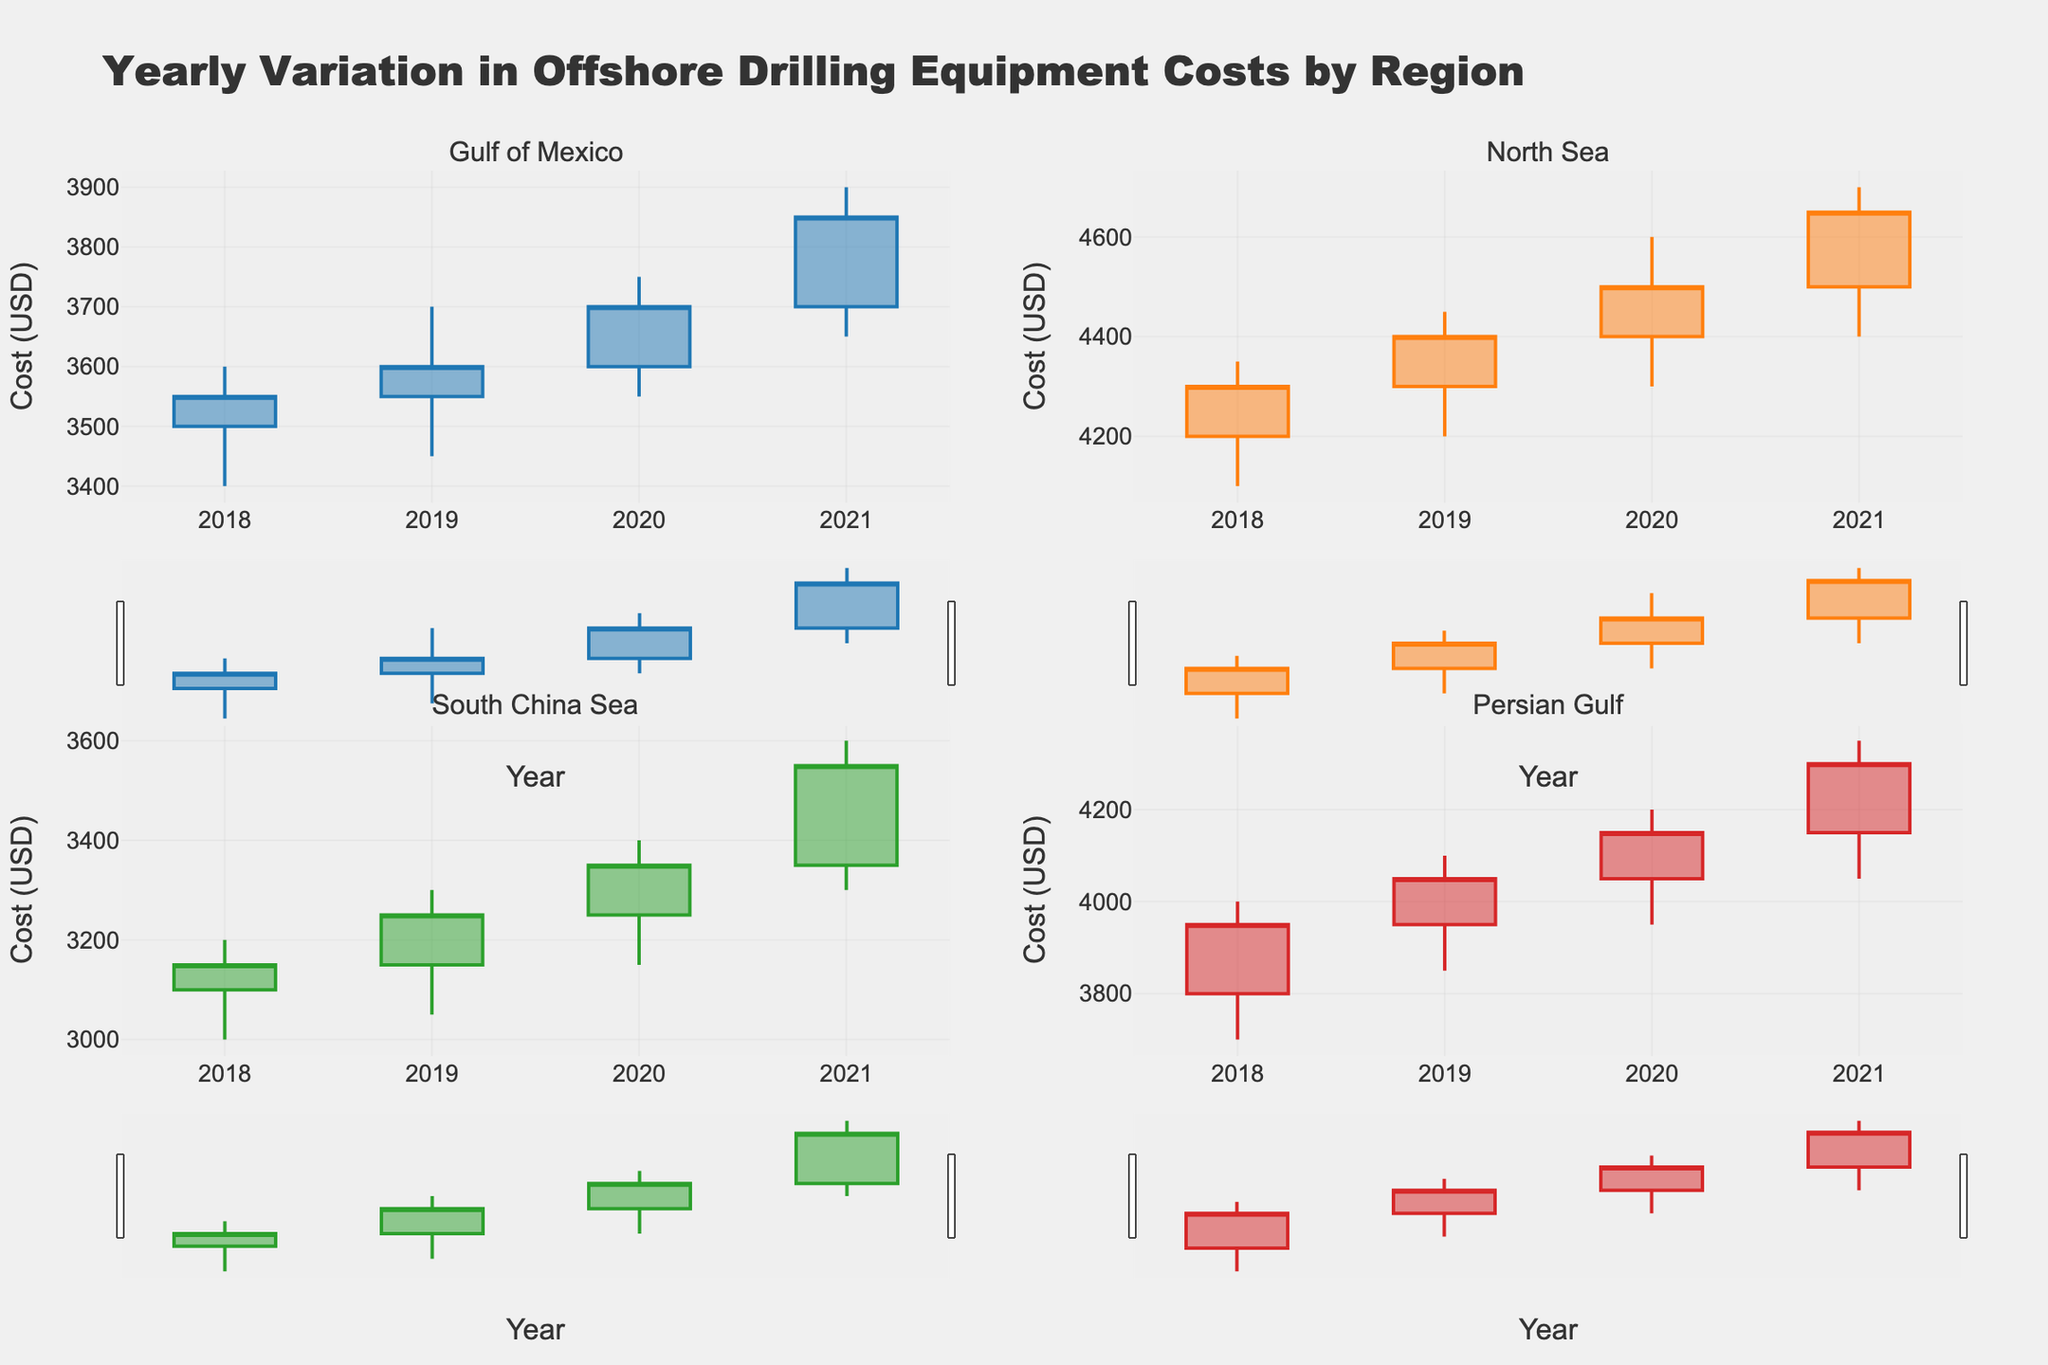How many years of data are shown in each region? Each region has data from 2018 to 2021. By looking at the x-axis for each subplot representing different regions, we can see the years listed are: 2018, 2019, 2020, and 2021.
Answer: 4 years Which region had the highest peak cost in 2021? By comparing the candlesticks for 2021 in each subplot, we see that the North Sea region had the highest peak cost. The high for North Sea in 2021 was 4700, which is greater than the high values for the other regions.
Answer: North Sea In which year did the South China Sea region have the lowest closing cost? Looking at the candlesticks for the South China Sea, focussing on the close values for each year, we observe that the closing cost in 2018 was 3150, which is lower than the close values for the other years: 2019, 2020, and 2021.
Answer: 2018 What was the average closing cost in the Gulf of Mexico region from 2018 to 2021? First, find the closing costs for each year: 3550 (2018), 3600 (2019), 3700 (2020), 3850 (2021). Then calculate the average: (3550 + 3600 + 3700 + 3850) / 4 = 3675.
Answer: 3675 Compare the trend of the opening costs in the Persian Gulf from 2018 to 2021. The opening costs for the Persian Gulf are: 3800 (2018), 3950 (2019), 4050 (2020), and 4150 (2021). We see an increasing trend each year.
Answer: Increasing trend In which regions did the costs never decrease from one year to the next, from 2018 to 2021? By examining the candlesticks, we see that in the North Sea and Persian Gulf, the closing costs do not decrease from year to year. North Sea: 4300 (2018), 4400 (2019), 4500 (2020), 4650 (2021). Persian Gulf: 3950 (2018), 4050 (2019), 4150 (2020), 4300 (2021).
Answer: North Sea, Persian Gulf Which region had the smallest range (difference between high and low) in 2019? Calculate the range for each region in 2019: Gulf of Mexico (3700-3450 = 250), North Sea (4450-4200 = 250), South China Sea (3300-3050 = 250), Persian Gulf (4100-3850 = 250). All regions have the same range.
Answer: All regions 